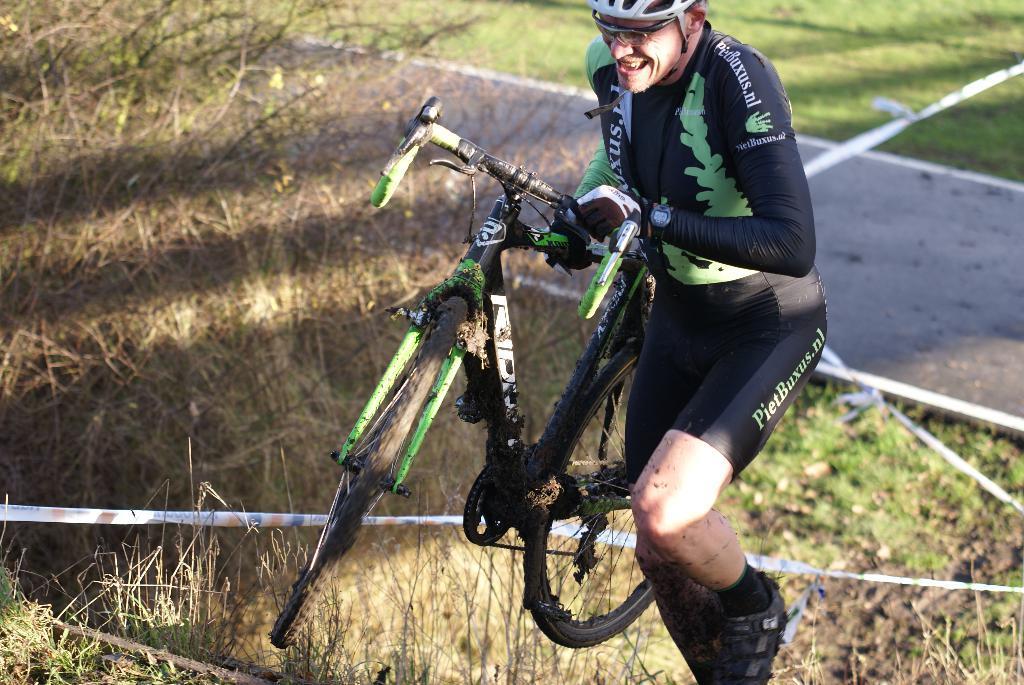Could you give a brief overview of what you see in this image? This picture consists of person wearing a black color dress and helmet and his smiling and holding a bi-cycle and at the bottom there is a rope and grass and in the middle there is a road. 